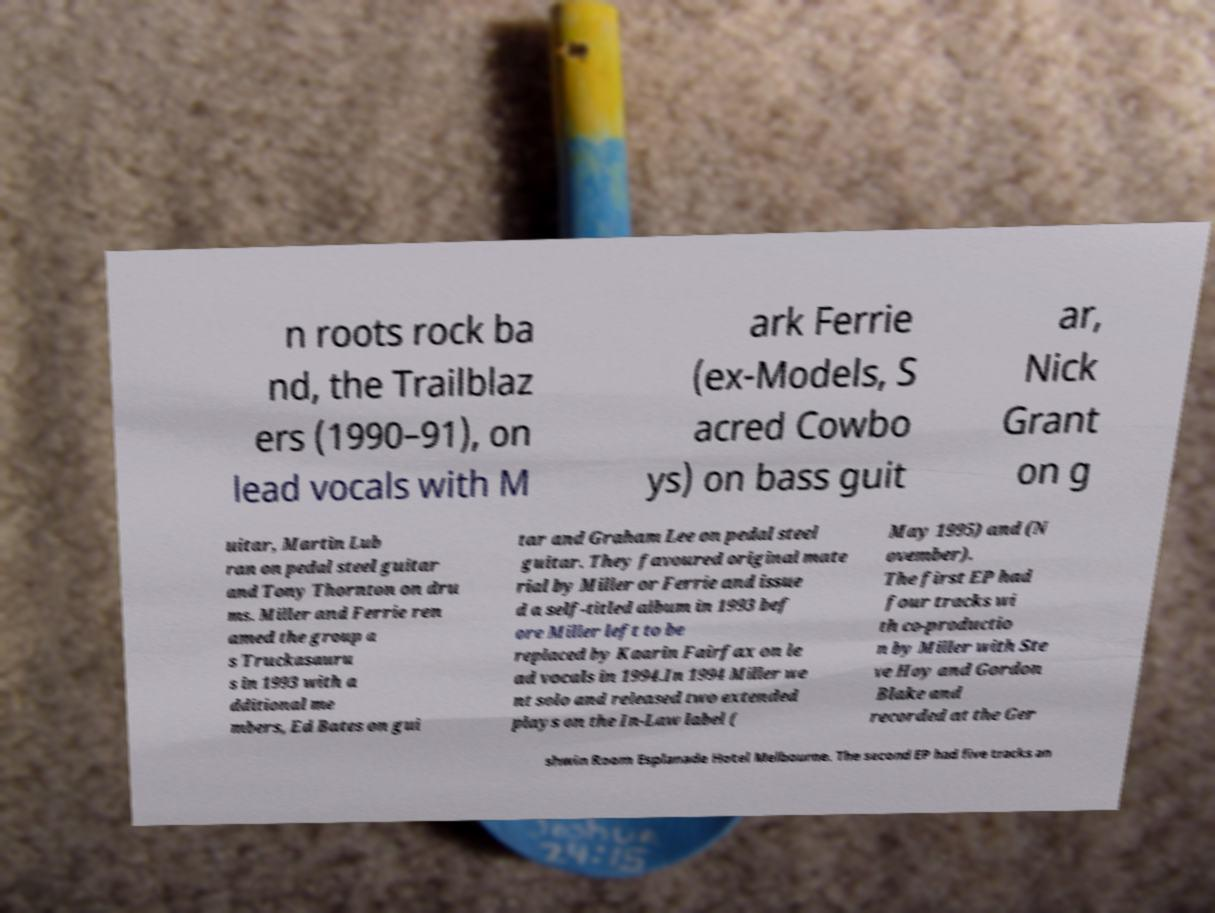For documentation purposes, I need the text within this image transcribed. Could you provide that? n roots rock ba nd, the Trailblaz ers (1990–91), on lead vocals with M ark Ferrie (ex-Models, S acred Cowbo ys) on bass guit ar, Nick Grant on g uitar, Martin Lub ran on pedal steel guitar and Tony Thornton on dru ms. Miller and Ferrie ren amed the group a s Truckasauru s in 1993 with a dditional me mbers, Ed Bates on gui tar and Graham Lee on pedal steel guitar. They favoured original mate rial by Miller or Ferrie and issue d a self-titled album in 1993 bef ore Miller left to be replaced by Kaarin Fairfax on le ad vocals in 1994.In 1994 Miller we nt solo and released two extended plays on the In-Law label ( May 1995) and (N ovember). The first EP had four tracks wi th co-productio n by Miller with Ste ve Hoy and Gordon Blake and recorded at the Ger shwin Room Esplanade Hotel Melbourne. The second EP had five tracks an 